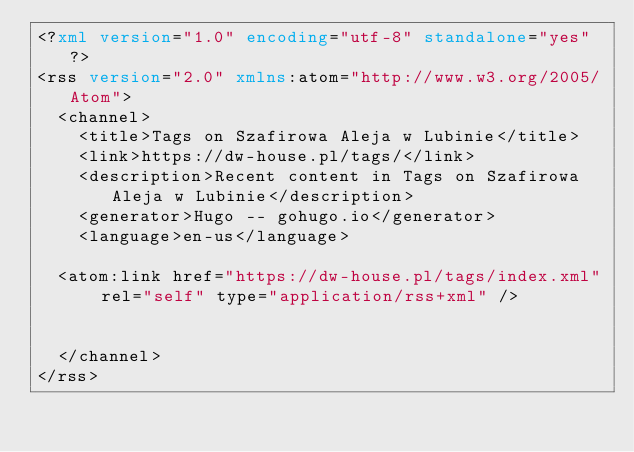Convert code to text. <code><loc_0><loc_0><loc_500><loc_500><_XML_><?xml version="1.0" encoding="utf-8" standalone="yes"?>
<rss version="2.0" xmlns:atom="http://www.w3.org/2005/Atom">
  <channel>
    <title>Tags on Szafirowa Aleja w Lubinie</title>
    <link>https://dw-house.pl/tags/</link>
    <description>Recent content in Tags on Szafirowa Aleja w Lubinie</description>
    <generator>Hugo -- gohugo.io</generator>
    <language>en-us</language>
    
	<atom:link href="https://dw-house.pl/tags/index.xml" rel="self" type="application/rss+xml" />
    
    
  </channel>
</rss></code> 